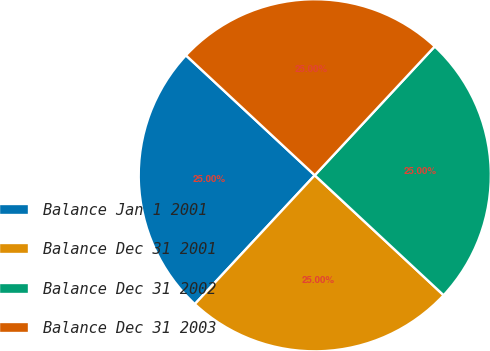<chart> <loc_0><loc_0><loc_500><loc_500><pie_chart><fcel>Balance Jan 1 2001<fcel>Balance Dec 31 2001<fcel>Balance Dec 31 2002<fcel>Balance Dec 31 2003<nl><fcel>25.0%<fcel>25.0%<fcel>25.0%<fcel>25.0%<nl></chart> 